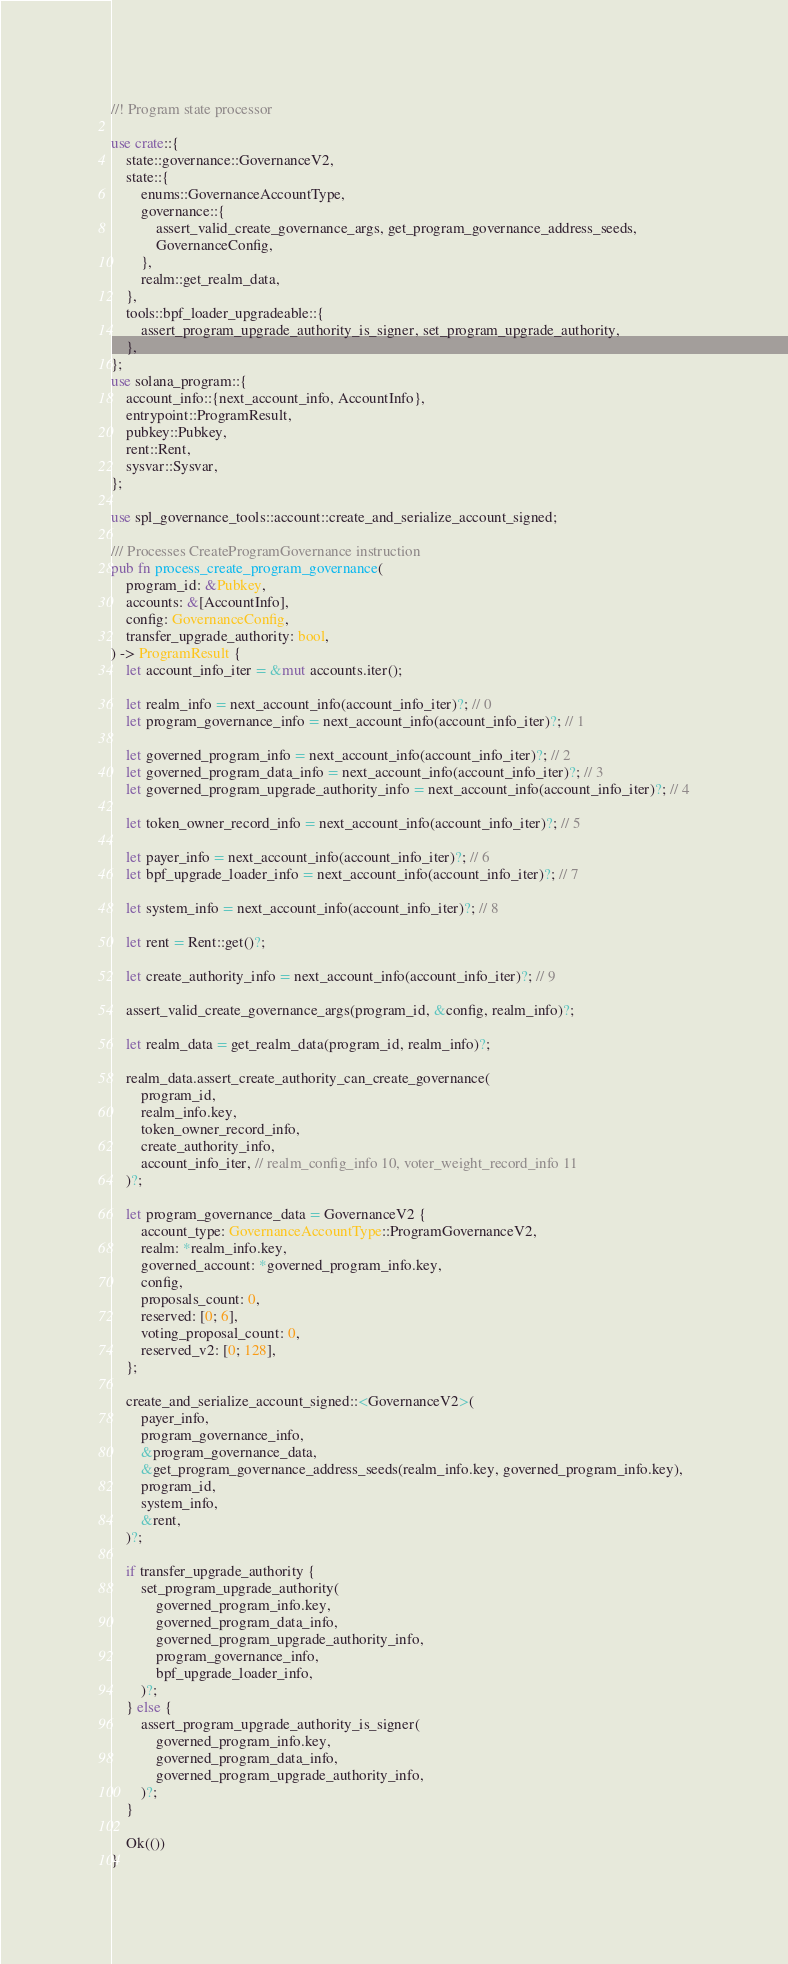<code> <loc_0><loc_0><loc_500><loc_500><_Rust_>//! Program state processor

use crate::{
    state::governance::GovernanceV2,
    state::{
        enums::GovernanceAccountType,
        governance::{
            assert_valid_create_governance_args, get_program_governance_address_seeds,
            GovernanceConfig,
        },
        realm::get_realm_data,
    },
    tools::bpf_loader_upgradeable::{
        assert_program_upgrade_authority_is_signer, set_program_upgrade_authority,
    },
};
use solana_program::{
    account_info::{next_account_info, AccountInfo},
    entrypoint::ProgramResult,
    pubkey::Pubkey,
    rent::Rent,
    sysvar::Sysvar,
};

use spl_governance_tools::account::create_and_serialize_account_signed;

/// Processes CreateProgramGovernance instruction
pub fn process_create_program_governance(
    program_id: &Pubkey,
    accounts: &[AccountInfo],
    config: GovernanceConfig,
    transfer_upgrade_authority: bool,
) -> ProgramResult {
    let account_info_iter = &mut accounts.iter();

    let realm_info = next_account_info(account_info_iter)?; // 0
    let program_governance_info = next_account_info(account_info_iter)?; // 1

    let governed_program_info = next_account_info(account_info_iter)?; // 2
    let governed_program_data_info = next_account_info(account_info_iter)?; // 3
    let governed_program_upgrade_authority_info = next_account_info(account_info_iter)?; // 4

    let token_owner_record_info = next_account_info(account_info_iter)?; // 5

    let payer_info = next_account_info(account_info_iter)?; // 6
    let bpf_upgrade_loader_info = next_account_info(account_info_iter)?; // 7

    let system_info = next_account_info(account_info_iter)?; // 8

    let rent = Rent::get()?;

    let create_authority_info = next_account_info(account_info_iter)?; // 9

    assert_valid_create_governance_args(program_id, &config, realm_info)?;

    let realm_data = get_realm_data(program_id, realm_info)?;

    realm_data.assert_create_authority_can_create_governance(
        program_id,
        realm_info.key,
        token_owner_record_info,
        create_authority_info,
        account_info_iter, // realm_config_info 10, voter_weight_record_info 11
    )?;

    let program_governance_data = GovernanceV2 {
        account_type: GovernanceAccountType::ProgramGovernanceV2,
        realm: *realm_info.key,
        governed_account: *governed_program_info.key,
        config,
        proposals_count: 0,
        reserved: [0; 6],
        voting_proposal_count: 0,
        reserved_v2: [0; 128],
    };

    create_and_serialize_account_signed::<GovernanceV2>(
        payer_info,
        program_governance_info,
        &program_governance_data,
        &get_program_governance_address_seeds(realm_info.key, governed_program_info.key),
        program_id,
        system_info,
        &rent,
    )?;

    if transfer_upgrade_authority {
        set_program_upgrade_authority(
            governed_program_info.key,
            governed_program_data_info,
            governed_program_upgrade_authority_info,
            program_governance_info,
            bpf_upgrade_loader_info,
        )?;
    } else {
        assert_program_upgrade_authority_is_signer(
            governed_program_info.key,
            governed_program_data_info,
            governed_program_upgrade_authority_info,
        )?;
    }

    Ok(())
}
</code> 